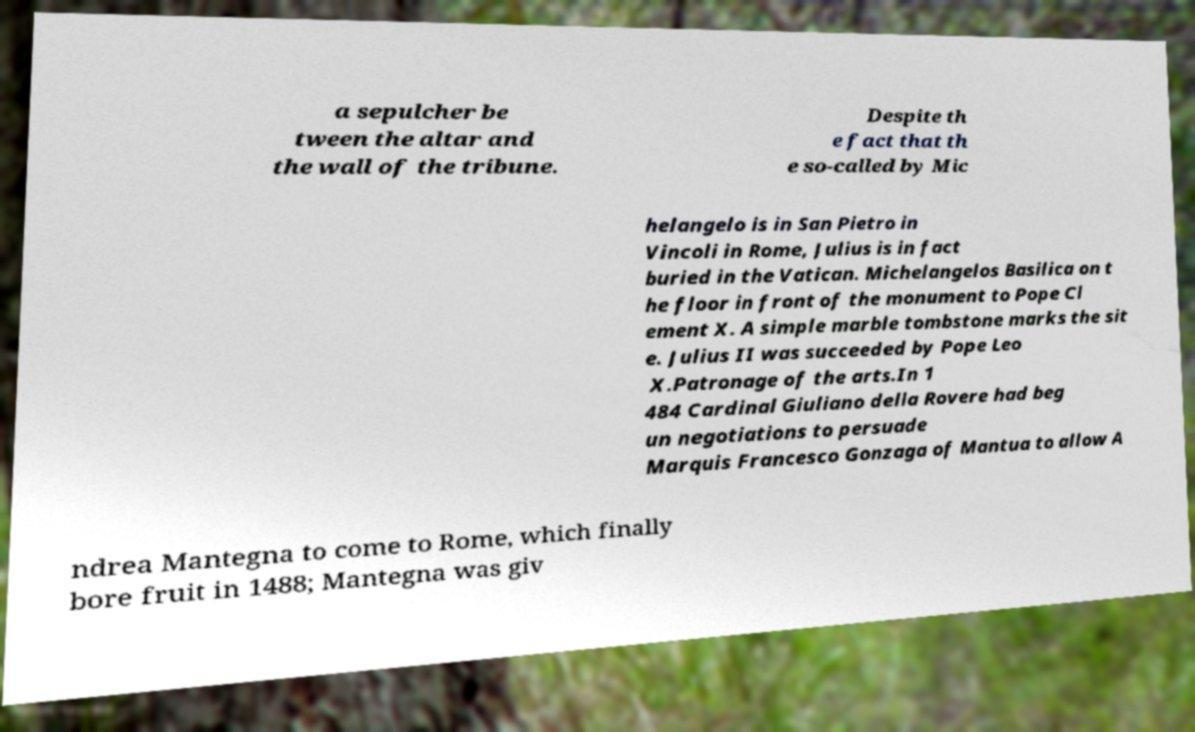Can you accurately transcribe the text from the provided image for me? a sepulcher be tween the altar and the wall of the tribune. Despite th e fact that th e so-called by Mic helangelo is in San Pietro in Vincoli in Rome, Julius is in fact buried in the Vatican. Michelangelos Basilica on t he floor in front of the monument to Pope Cl ement X. A simple marble tombstone marks the sit e. Julius II was succeeded by Pope Leo X.Patronage of the arts.In 1 484 Cardinal Giuliano della Rovere had beg un negotiations to persuade Marquis Francesco Gonzaga of Mantua to allow A ndrea Mantegna to come to Rome, which finally bore fruit in 1488; Mantegna was giv 